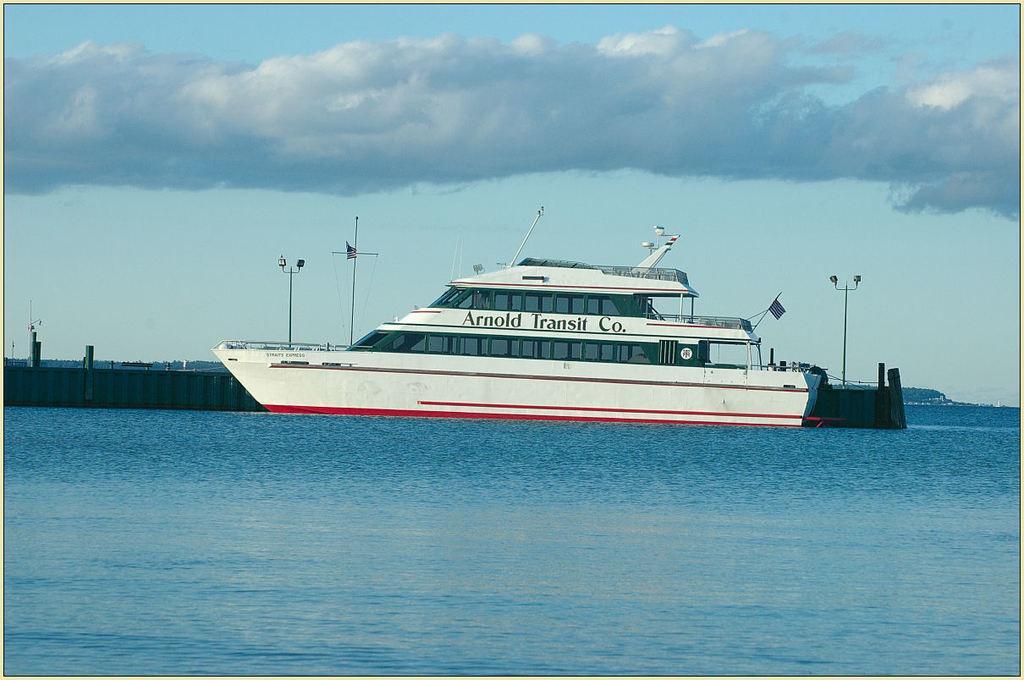Describe this image in one or two sentences. In this image there is a ship on the river, behind the ship there is a railing and few poles, mountains and the sky. 